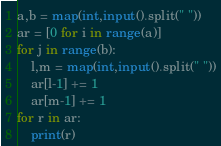Convert code to text. <code><loc_0><loc_0><loc_500><loc_500><_Python_>a,b = map(int,input().split(" "))
ar = [0 for i in range(a)]
for j in range(b):
    l,m = map(int,input().split(" "))
    ar[l-1] += 1
    ar[m-1] += 1
for r in ar:
    print(r)</code> 